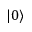Convert formula to latex. <formula><loc_0><loc_0><loc_500><loc_500>| 0 \rangle</formula> 